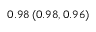<formula> <loc_0><loc_0><loc_500><loc_500>0 . 9 8 \left ( 0 . 9 8 , 0 . 9 6 \right )</formula> 